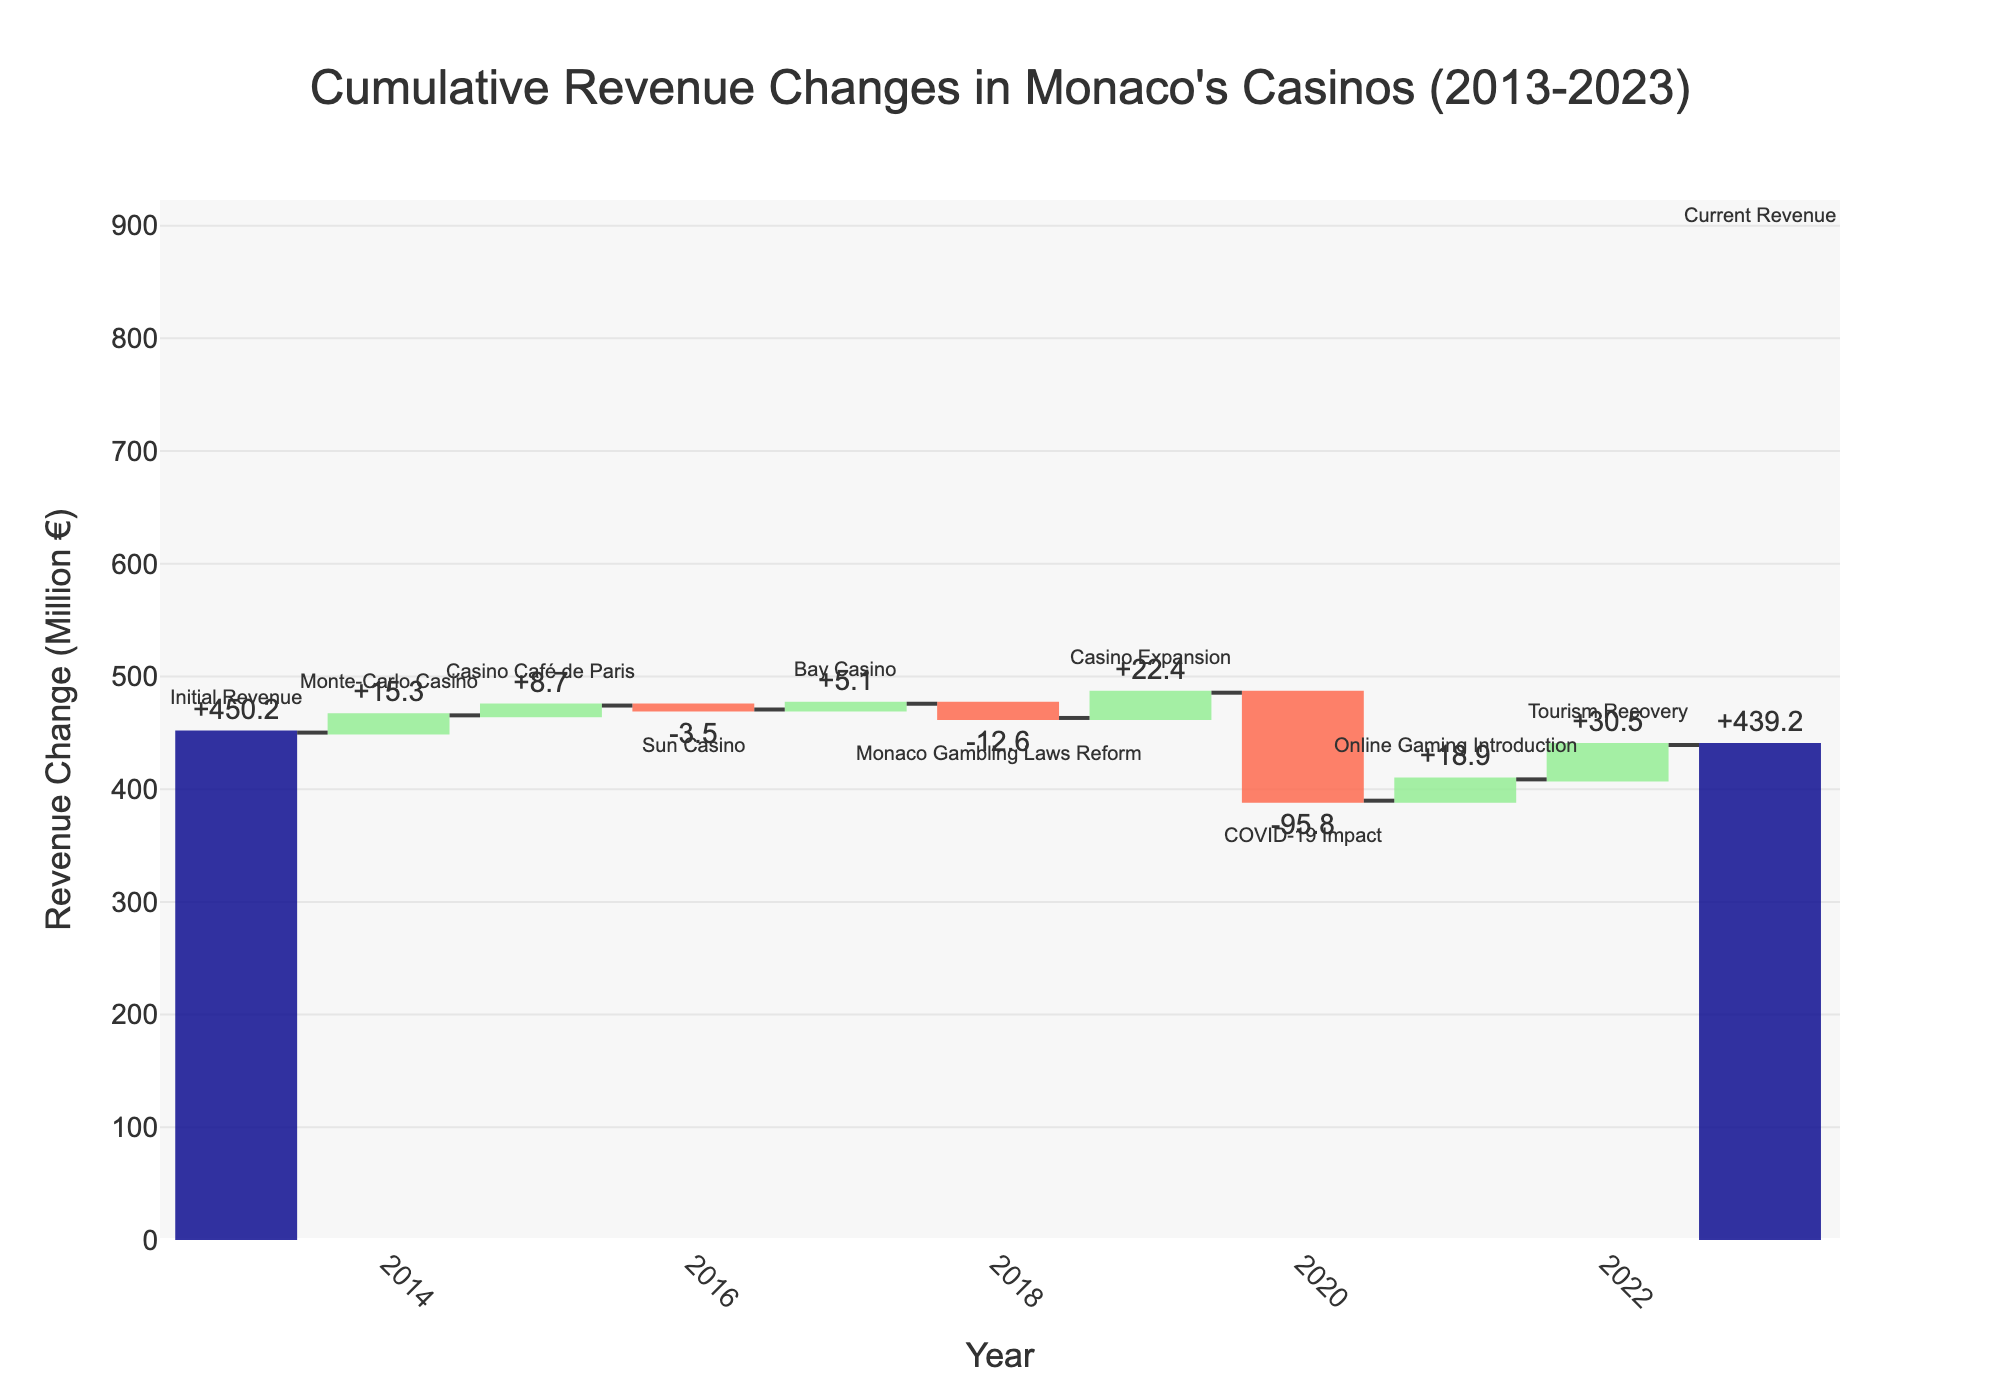How much did the Monte-Carlo Casino contribute to the cumulative revenue change in 2014? From the figure, look at the year 2014 and identify the value associated with the Monte-Carlo Casino. The figure shows that Monte-Carlo Casino contributed +15.3 million €.
Answer: +15.3 million € What was the impact of Monaco Gambling Laws Reform on the cumulative revenue change? Find the value corresponding to Monaco Gambling Laws Reform in 2018. The figure shows it had a negative impact of -12.6 million €.
Answer: -12.6 million € Compare the change in revenue between the Sun Casino in 2016 and the online gaming introduction in 2021. Which had a larger impact? Look at the values for Sun Casino in 2016 (-3.5 million €) and online gaming introduction in 2021 (+18.9 million €). The positive impact of the online gaming introduction (+18.9 million €) is larger than the negative impact of the Sun Casino (-3.5 million €).
Answer: Online gaming introduction Which year experienced the most significant decline in revenue? Identify the year with the largest negative bar. The figure displays that the most significant decline happened in 2020 due to the COVID-19 Impact with -95.8 million €.
Answer: 2020 By how much did tourism recovery in 2022 increase the cumulative revenue? Find the value for tourism recovery in 2022. The figure shows that it increased the cumulative revenue by +30.5 million €.
Answer: +30.5 million € What is the cumulative revenue in 2023 compared to the initial revenue in 2013? The initial revenue in 2013 is 450.2 million €, while the cumulative revenue in 2023 is 439.2 million €. The difference is 450.2 - 439.2 = 11 million € decrease in the cumulative revenue over the decade.
Answer: 11 million € decrease How did the Casino Expansion in 2019 impact the cumulative revenue? Find the value for the Casino Expansion in 2019. The cumulative revenue increased by +22.4 million €.
Answer: +22.4 million € What was the overall trend of cumulative revenue changes over the decade? By examining the sum of all contributions and their signs, the overall trend reflects fluctuations with some gains, losses, and significant reductions (e.g., COVID-19 impact), ending slightly less than the initial revenue. Overall, cumulative revenue slightly decreased from 450.2 million € to 439.2 million €.
Answer: Slight decrease Sum up the cumulative gains and losses in the given period. Was there a net increase or decrease? Add up each positive and negative value from 2014 to 2022. Summing gains: 15.3 + 8.7 + 5.1 + 22.4 + 18.9 + 30.5 = 100.9 million €. Summing losses: -3.5 - 12.6 - 95.8 = -111.9 million €. Net change: 100.9 - 111.9 = -11 million €. Thus, there was a net decrease of 11 million €.
Answer: Net decrease 